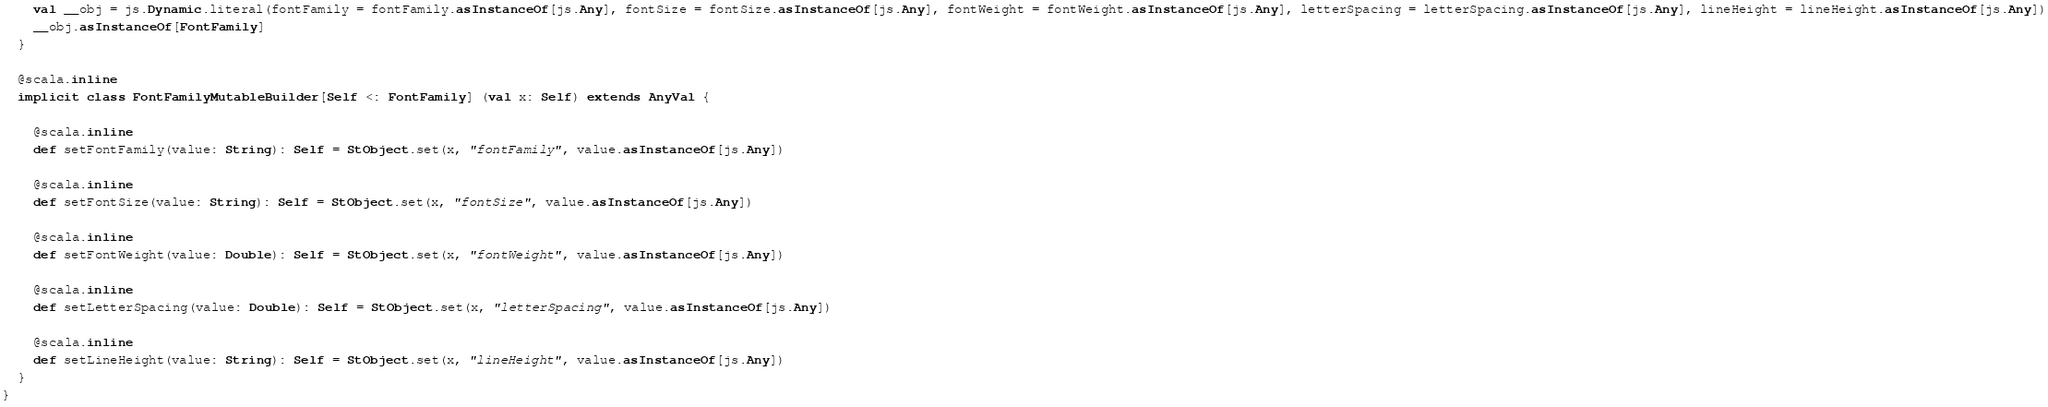<code> <loc_0><loc_0><loc_500><loc_500><_Scala_>    val __obj = js.Dynamic.literal(fontFamily = fontFamily.asInstanceOf[js.Any], fontSize = fontSize.asInstanceOf[js.Any], fontWeight = fontWeight.asInstanceOf[js.Any], letterSpacing = letterSpacing.asInstanceOf[js.Any], lineHeight = lineHeight.asInstanceOf[js.Any])
    __obj.asInstanceOf[FontFamily]
  }
  
  @scala.inline
  implicit class FontFamilyMutableBuilder[Self <: FontFamily] (val x: Self) extends AnyVal {
    
    @scala.inline
    def setFontFamily(value: String): Self = StObject.set(x, "fontFamily", value.asInstanceOf[js.Any])
    
    @scala.inline
    def setFontSize(value: String): Self = StObject.set(x, "fontSize", value.asInstanceOf[js.Any])
    
    @scala.inline
    def setFontWeight(value: Double): Self = StObject.set(x, "fontWeight", value.asInstanceOf[js.Any])
    
    @scala.inline
    def setLetterSpacing(value: Double): Self = StObject.set(x, "letterSpacing", value.asInstanceOf[js.Any])
    
    @scala.inline
    def setLineHeight(value: String): Self = StObject.set(x, "lineHeight", value.asInstanceOf[js.Any])
  }
}
</code> 